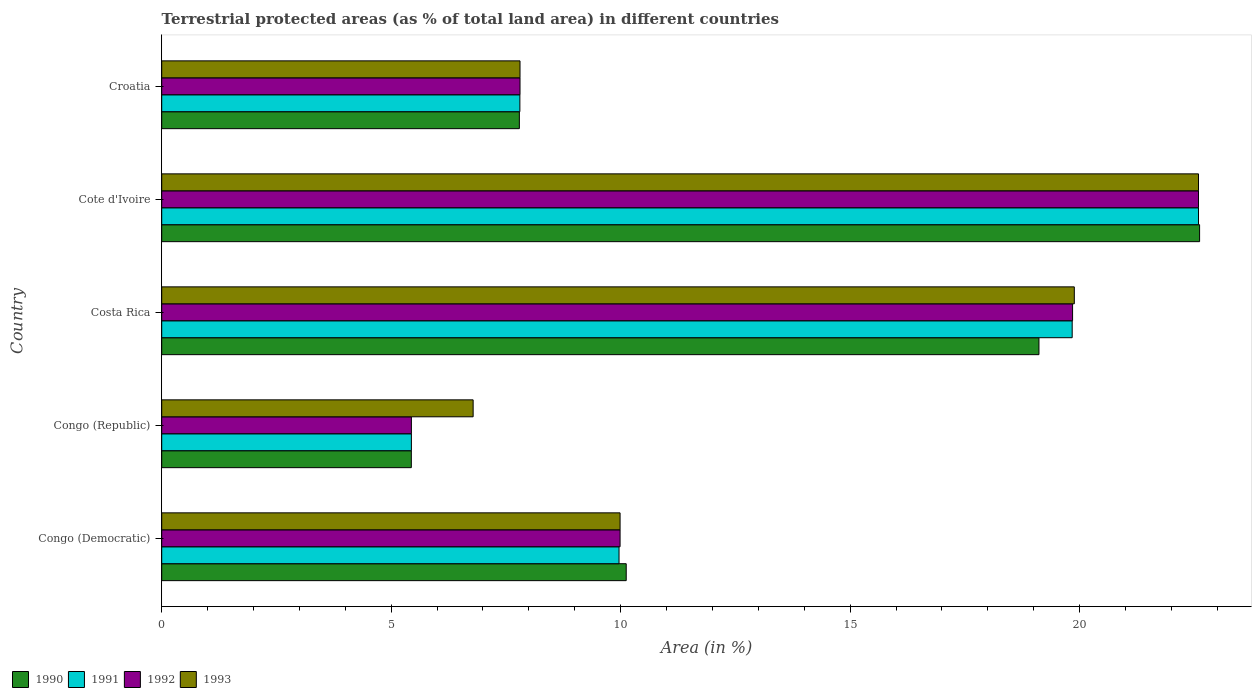Are the number of bars per tick equal to the number of legend labels?
Make the answer very short. Yes. Are the number of bars on each tick of the Y-axis equal?
Provide a succinct answer. Yes. How many bars are there on the 5th tick from the top?
Give a very brief answer. 4. What is the label of the 3rd group of bars from the top?
Give a very brief answer. Costa Rica. What is the percentage of terrestrial protected land in 1992 in Cote d'Ivoire?
Make the answer very short. 22.59. Across all countries, what is the maximum percentage of terrestrial protected land in 1993?
Your response must be concise. 22.59. Across all countries, what is the minimum percentage of terrestrial protected land in 1993?
Ensure brevity in your answer.  6.79. In which country was the percentage of terrestrial protected land in 1992 maximum?
Your response must be concise. Cote d'Ivoire. In which country was the percentage of terrestrial protected land in 1991 minimum?
Your answer should be very brief. Congo (Republic). What is the total percentage of terrestrial protected land in 1990 in the graph?
Offer a terse response. 65.08. What is the difference between the percentage of terrestrial protected land in 1991 in Costa Rica and that in Croatia?
Provide a short and direct response. 12.03. What is the difference between the percentage of terrestrial protected land in 1992 in Congo (Democratic) and the percentage of terrestrial protected land in 1993 in Congo (Republic)?
Provide a succinct answer. 3.2. What is the average percentage of terrestrial protected land in 1991 per country?
Ensure brevity in your answer.  13.13. What is the difference between the percentage of terrestrial protected land in 1993 and percentage of terrestrial protected land in 1991 in Congo (Republic)?
Offer a terse response. 1.35. What is the ratio of the percentage of terrestrial protected land in 1990 in Congo (Republic) to that in Cote d'Ivoire?
Provide a succinct answer. 0.24. Is the percentage of terrestrial protected land in 1992 in Congo (Democratic) less than that in Congo (Republic)?
Offer a terse response. No. Is the difference between the percentage of terrestrial protected land in 1993 in Cote d'Ivoire and Croatia greater than the difference between the percentage of terrestrial protected land in 1991 in Cote d'Ivoire and Croatia?
Your answer should be compact. No. What is the difference between the highest and the second highest percentage of terrestrial protected land in 1992?
Make the answer very short. 2.74. What is the difference between the highest and the lowest percentage of terrestrial protected land in 1991?
Provide a short and direct response. 17.15. Is it the case that in every country, the sum of the percentage of terrestrial protected land in 1993 and percentage of terrestrial protected land in 1991 is greater than the sum of percentage of terrestrial protected land in 1992 and percentage of terrestrial protected land in 1990?
Make the answer very short. No. Is it the case that in every country, the sum of the percentage of terrestrial protected land in 1993 and percentage of terrestrial protected land in 1990 is greater than the percentage of terrestrial protected land in 1991?
Make the answer very short. Yes. How many bars are there?
Offer a very short reply. 20. Are all the bars in the graph horizontal?
Keep it short and to the point. Yes. Does the graph contain any zero values?
Make the answer very short. No. Where does the legend appear in the graph?
Provide a succinct answer. Bottom left. What is the title of the graph?
Your answer should be compact. Terrestrial protected areas (as % of total land area) in different countries. What is the label or title of the X-axis?
Provide a succinct answer. Area (in %). What is the Area (in %) of 1990 in Congo (Democratic)?
Make the answer very short. 10.12. What is the Area (in %) of 1991 in Congo (Democratic)?
Your answer should be compact. 9.96. What is the Area (in %) of 1992 in Congo (Democratic)?
Keep it short and to the point. 9.99. What is the Area (in %) of 1993 in Congo (Democratic)?
Your response must be concise. 9.99. What is the Area (in %) in 1990 in Congo (Republic)?
Make the answer very short. 5.44. What is the Area (in %) of 1991 in Congo (Republic)?
Your response must be concise. 5.44. What is the Area (in %) in 1992 in Congo (Republic)?
Offer a terse response. 5.44. What is the Area (in %) of 1993 in Congo (Republic)?
Your response must be concise. 6.79. What is the Area (in %) in 1990 in Costa Rica?
Ensure brevity in your answer.  19.11. What is the Area (in %) in 1991 in Costa Rica?
Your answer should be compact. 19.84. What is the Area (in %) in 1992 in Costa Rica?
Provide a succinct answer. 19.85. What is the Area (in %) in 1993 in Costa Rica?
Provide a succinct answer. 19.88. What is the Area (in %) in 1990 in Cote d'Ivoire?
Make the answer very short. 22.61. What is the Area (in %) in 1991 in Cote d'Ivoire?
Ensure brevity in your answer.  22.59. What is the Area (in %) in 1992 in Cote d'Ivoire?
Ensure brevity in your answer.  22.59. What is the Area (in %) in 1993 in Cote d'Ivoire?
Offer a terse response. 22.59. What is the Area (in %) in 1990 in Croatia?
Your answer should be very brief. 7.79. What is the Area (in %) of 1991 in Croatia?
Make the answer very short. 7.8. What is the Area (in %) in 1992 in Croatia?
Your response must be concise. 7.81. What is the Area (in %) of 1993 in Croatia?
Offer a very short reply. 7.81. Across all countries, what is the maximum Area (in %) of 1990?
Keep it short and to the point. 22.61. Across all countries, what is the maximum Area (in %) of 1991?
Offer a terse response. 22.59. Across all countries, what is the maximum Area (in %) of 1992?
Make the answer very short. 22.59. Across all countries, what is the maximum Area (in %) of 1993?
Give a very brief answer. 22.59. Across all countries, what is the minimum Area (in %) of 1990?
Ensure brevity in your answer.  5.44. Across all countries, what is the minimum Area (in %) in 1991?
Your answer should be very brief. 5.44. Across all countries, what is the minimum Area (in %) of 1992?
Your answer should be very brief. 5.44. Across all countries, what is the minimum Area (in %) of 1993?
Make the answer very short. 6.79. What is the total Area (in %) of 1990 in the graph?
Give a very brief answer. 65.08. What is the total Area (in %) in 1991 in the graph?
Make the answer very short. 65.64. What is the total Area (in %) of 1992 in the graph?
Make the answer very short. 65.67. What is the total Area (in %) in 1993 in the graph?
Give a very brief answer. 67.05. What is the difference between the Area (in %) of 1990 in Congo (Democratic) and that in Congo (Republic)?
Your response must be concise. 4.68. What is the difference between the Area (in %) in 1991 in Congo (Democratic) and that in Congo (Republic)?
Ensure brevity in your answer.  4.52. What is the difference between the Area (in %) in 1992 in Congo (Democratic) and that in Congo (Republic)?
Give a very brief answer. 4.55. What is the difference between the Area (in %) in 1993 in Congo (Democratic) and that in Congo (Republic)?
Your answer should be compact. 3.2. What is the difference between the Area (in %) in 1990 in Congo (Democratic) and that in Costa Rica?
Keep it short and to the point. -8.99. What is the difference between the Area (in %) of 1991 in Congo (Democratic) and that in Costa Rica?
Offer a terse response. -9.87. What is the difference between the Area (in %) in 1992 in Congo (Democratic) and that in Costa Rica?
Your answer should be very brief. -9.86. What is the difference between the Area (in %) in 1993 in Congo (Democratic) and that in Costa Rica?
Keep it short and to the point. -9.9. What is the difference between the Area (in %) of 1990 in Congo (Democratic) and that in Cote d'Ivoire?
Keep it short and to the point. -12.49. What is the difference between the Area (in %) of 1991 in Congo (Democratic) and that in Cote d'Ivoire?
Keep it short and to the point. -12.63. What is the difference between the Area (in %) of 1992 in Congo (Democratic) and that in Cote d'Ivoire?
Keep it short and to the point. -12.6. What is the difference between the Area (in %) of 1993 in Congo (Democratic) and that in Cote d'Ivoire?
Your answer should be compact. -12.6. What is the difference between the Area (in %) of 1990 in Congo (Democratic) and that in Croatia?
Make the answer very short. 2.33. What is the difference between the Area (in %) in 1991 in Congo (Democratic) and that in Croatia?
Ensure brevity in your answer.  2.16. What is the difference between the Area (in %) in 1992 in Congo (Democratic) and that in Croatia?
Your answer should be compact. 2.18. What is the difference between the Area (in %) of 1993 in Congo (Democratic) and that in Croatia?
Offer a very short reply. 2.18. What is the difference between the Area (in %) of 1990 in Congo (Republic) and that in Costa Rica?
Provide a short and direct response. -13.67. What is the difference between the Area (in %) in 1991 in Congo (Republic) and that in Costa Rica?
Make the answer very short. -14.4. What is the difference between the Area (in %) of 1992 in Congo (Republic) and that in Costa Rica?
Offer a very short reply. -14.41. What is the difference between the Area (in %) of 1993 in Congo (Republic) and that in Costa Rica?
Your answer should be compact. -13.1. What is the difference between the Area (in %) of 1990 in Congo (Republic) and that in Cote d'Ivoire?
Your answer should be compact. -17.17. What is the difference between the Area (in %) in 1991 in Congo (Republic) and that in Cote d'Ivoire?
Offer a very short reply. -17.15. What is the difference between the Area (in %) of 1992 in Congo (Republic) and that in Cote d'Ivoire?
Keep it short and to the point. -17.15. What is the difference between the Area (in %) of 1993 in Congo (Republic) and that in Cote d'Ivoire?
Make the answer very short. -15.8. What is the difference between the Area (in %) of 1990 in Congo (Republic) and that in Croatia?
Make the answer very short. -2.35. What is the difference between the Area (in %) in 1991 in Congo (Republic) and that in Croatia?
Give a very brief answer. -2.36. What is the difference between the Area (in %) in 1992 in Congo (Republic) and that in Croatia?
Give a very brief answer. -2.37. What is the difference between the Area (in %) in 1993 in Congo (Republic) and that in Croatia?
Your answer should be very brief. -1.02. What is the difference between the Area (in %) of 1991 in Costa Rica and that in Cote d'Ivoire?
Make the answer very short. -2.75. What is the difference between the Area (in %) of 1992 in Costa Rica and that in Cote d'Ivoire?
Your response must be concise. -2.74. What is the difference between the Area (in %) in 1993 in Costa Rica and that in Cote d'Ivoire?
Provide a succinct answer. -2.71. What is the difference between the Area (in %) of 1990 in Costa Rica and that in Croatia?
Your answer should be compact. 11.32. What is the difference between the Area (in %) in 1991 in Costa Rica and that in Croatia?
Keep it short and to the point. 12.03. What is the difference between the Area (in %) in 1992 in Costa Rica and that in Croatia?
Your response must be concise. 12.04. What is the difference between the Area (in %) in 1993 in Costa Rica and that in Croatia?
Your answer should be very brief. 12.08. What is the difference between the Area (in %) of 1990 in Cote d'Ivoire and that in Croatia?
Give a very brief answer. 14.82. What is the difference between the Area (in %) of 1991 in Cote d'Ivoire and that in Croatia?
Provide a succinct answer. 14.79. What is the difference between the Area (in %) of 1992 in Cote d'Ivoire and that in Croatia?
Your answer should be very brief. 14.78. What is the difference between the Area (in %) in 1993 in Cote d'Ivoire and that in Croatia?
Your response must be concise. 14.78. What is the difference between the Area (in %) of 1990 in Congo (Democratic) and the Area (in %) of 1991 in Congo (Republic)?
Give a very brief answer. 4.68. What is the difference between the Area (in %) in 1990 in Congo (Democratic) and the Area (in %) in 1992 in Congo (Republic)?
Your answer should be compact. 4.68. What is the difference between the Area (in %) of 1990 in Congo (Democratic) and the Area (in %) of 1993 in Congo (Republic)?
Provide a short and direct response. 3.34. What is the difference between the Area (in %) in 1991 in Congo (Democratic) and the Area (in %) in 1992 in Congo (Republic)?
Keep it short and to the point. 4.52. What is the difference between the Area (in %) in 1991 in Congo (Democratic) and the Area (in %) in 1993 in Congo (Republic)?
Give a very brief answer. 3.18. What is the difference between the Area (in %) in 1992 in Congo (Democratic) and the Area (in %) in 1993 in Congo (Republic)?
Provide a short and direct response. 3.2. What is the difference between the Area (in %) in 1990 in Congo (Democratic) and the Area (in %) in 1991 in Costa Rica?
Make the answer very short. -9.72. What is the difference between the Area (in %) in 1990 in Congo (Democratic) and the Area (in %) in 1992 in Costa Rica?
Your response must be concise. -9.73. What is the difference between the Area (in %) of 1990 in Congo (Democratic) and the Area (in %) of 1993 in Costa Rica?
Give a very brief answer. -9.76. What is the difference between the Area (in %) of 1991 in Congo (Democratic) and the Area (in %) of 1992 in Costa Rica?
Provide a succinct answer. -9.88. What is the difference between the Area (in %) of 1991 in Congo (Democratic) and the Area (in %) of 1993 in Costa Rica?
Your answer should be compact. -9.92. What is the difference between the Area (in %) of 1992 in Congo (Democratic) and the Area (in %) of 1993 in Costa Rica?
Offer a very short reply. -9.9. What is the difference between the Area (in %) in 1990 in Congo (Democratic) and the Area (in %) in 1991 in Cote d'Ivoire?
Your answer should be compact. -12.47. What is the difference between the Area (in %) of 1990 in Congo (Democratic) and the Area (in %) of 1992 in Cote d'Ivoire?
Ensure brevity in your answer.  -12.47. What is the difference between the Area (in %) of 1990 in Congo (Democratic) and the Area (in %) of 1993 in Cote d'Ivoire?
Your answer should be compact. -12.47. What is the difference between the Area (in %) in 1991 in Congo (Democratic) and the Area (in %) in 1992 in Cote d'Ivoire?
Ensure brevity in your answer.  -12.63. What is the difference between the Area (in %) in 1991 in Congo (Democratic) and the Area (in %) in 1993 in Cote d'Ivoire?
Provide a short and direct response. -12.63. What is the difference between the Area (in %) of 1992 in Congo (Democratic) and the Area (in %) of 1993 in Cote d'Ivoire?
Your answer should be compact. -12.6. What is the difference between the Area (in %) of 1990 in Congo (Democratic) and the Area (in %) of 1991 in Croatia?
Ensure brevity in your answer.  2.32. What is the difference between the Area (in %) of 1990 in Congo (Democratic) and the Area (in %) of 1992 in Croatia?
Your answer should be compact. 2.31. What is the difference between the Area (in %) of 1990 in Congo (Democratic) and the Area (in %) of 1993 in Croatia?
Keep it short and to the point. 2.31. What is the difference between the Area (in %) of 1991 in Congo (Democratic) and the Area (in %) of 1992 in Croatia?
Offer a very short reply. 2.16. What is the difference between the Area (in %) of 1991 in Congo (Democratic) and the Area (in %) of 1993 in Croatia?
Your answer should be very brief. 2.16. What is the difference between the Area (in %) in 1992 in Congo (Democratic) and the Area (in %) in 1993 in Croatia?
Keep it short and to the point. 2.18. What is the difference between the Area (in %) of 1990 in Congo (Republic) and the Area (in %) of 1991 in Costa Rica?
Offer a very short reply. -14.4. What is the difference between the Area (in %) in 1990 in Congo (Republic) and the Area (in %) in 1992 in Costa Rica?
Give a very brief answer. -14.41. What is the difference between the Area (in %) in 1990 in Congo (Republic) and the Area (in %) in 1993 in Costa Rica?
Give a very brief answer. -14.45. What is the difference between the Area (in %) in 1991 in Congo (Republic) and the Area (in %) in 1992 in Costa Rica?
Offer a terse response. -14.41. What is the difference between the Area (in %) of 1991 in Congo (Republic) and the Area (in %) of 1993 in Costa Rica?
Offer a terse response. -14.44. What is the difference between the Area (in %) in 1992 in Congo (Republic) and the Area (in %) in 1993 in Costa Rica?
Offer a terse response. -14.44. What is the difference between the Area (in %) of 1990 in Congo (Republic) and the Area (in %) of 1991 in Cote d'Ivoire?
Your response must be concise. -17.15. What is the difference between the Area (in %) of 1990 in Congo (Republic) and the Area (in %) of 1992 in Cote d'Ivoire?
Offer a terse response. -17.15. What is the difference between the Area (in %) in 1990 in Congo (Republic) and the Area (in %) in 1993 in Cote d'Ivoire?
Your answer should be compact. -17.15. What is the difference between the Area (in %) in 1991 in Congo (Republic) and the Area (in %) in 1992 in Cote d'Ivoire?
Keep it short and to the point. -17.15. What is the difference between the Area (in %) in 1991 in Congo (Republic) and the Area (in %) in 1993 in Cote d'Ivoire?
Your answer should be compact. -17.15. What is the difference between the Area (in %) in 1992 in Congo (Republic) and the Area (in %) in 1993 in Cote d'Ivoire?
Keep it short and to the point. -17.15. What is the difference between the Area (in %) of 1990 in Congo (Republic) and the Area (in %) of 1991 in Croatia?
Give a very brief answer. -2.37. What is the difference between the Area (in %) in 1990 in Congo (Republic) and the Area (in %) in 1992 in Croatia?
Your answer should be very brief. -2.37. What is the difference between the Area (in %) in 1990 in Congo (Republic) and the Area (in %) in 1993 in Croatia?
Your answer should be compact. -2.37. What is the difference between the Area (in %) of 1991 in Congo (Republic) and the Area (in %) of 1992 in Croatia?
Give a very brief answer. -2.37. What is the difference between the Area (in %) of 1991 in Congo (Republic) and the Area (in %) of 1993 in Croatia?
Give a very brief answer. -2.37. What is the difference between the Area (in %) of 1992 in Congo (Republic) and the Area (in %) of 1993 in Croatia?
Offer a very short reply. -2.37. What is the difference between the Area (in %) of 1990 in Costa Rica and the Area (in %) of 1991 in Cote d'Ivoire?
Keep it short and to the point. -3.48. What is the difference between the Area (in %) in 1990 in Costa Rica and the Area (in %) in 1992 in Cote d'Ivoire?
Provide a short and direct response. -3.48. What is the difference between the Area (in %) of 1990 in Costa Rica and the Area (in %) of 1993 in Cote d'Ivoire?
Your answer should be compact. -3.48. What is the difference between the Area (in %) in 1991 in Costa Rica and the Area (in %) in 1992 in Cote d'Ivoire?
Offer a terse response. -2.75. What is the difference between the Area (in %) in 1991 in Costa Rica and the Area (in %) in 1993 in Cote d'Ivoire?
Make the answer very short. -2.75. What is the difference between the Area (in %) in 1992 in Costa Rica and the Area (in %) in 1993 in Cote d'Ivoire?
Provide a succinct answer. -2.74. What is the difference between the Area (in %) of 1990 in Costa Rica and the Area (in %) of 1991 in Croatia?
Make the answer very short. 11.31. What is the difference between the Area (in %) in 1990 in Costa Rica and the Area (in %) in 1992 in Croatia?
Keep it short and to the point. 11.31. What is the difference between the Area (in %) in 1990 in Costa Rica and the Area (in %) in 1993 in Croatia?
Your answer should be compact. 11.31. What is the difference between the Area (in %) of 1991 in Costa Rica and the Area (in %) of 1992 in Croatia?
Your answer should be compact. 12.03. What is the difference between the Area (in %) of 1991 in Costa Rica and the Area (in %) of 1993 in Croatia?
Give a very brief answer. 12.03. What is the difference between the Area (in %) in 1992 in Costa Rica and the Area (in %) in 1993 in Croatia?
Provide a succinct answer. 12.04. What is the difference between the Area (in %) of 1990 in Cote d'Ivoire and the Area (in %) of 1991 in Croatia?
Provide a short and direct response. 14.81. What is the difference between the Area (in %) in 1990 in Cote d'Ivoire and the Area (in %) in 1992 in Croatia?
Offer a terse response. 14.81. What is the difference between the Area (in %) in 1990 in Cote d'Ivoire and the Area (in %) in 1993 in Croatia?
Ensure brevity in your answer.  14.81. What is the difference between the Area (in %) in 1991 in Cote d'Ivoire and the Area (in %) in 1992 in Croatia?
Offer a very short reply. 14.78. What is the difference between the Area (in %) of 1991 in Cote d'Ivoire and the Area (in %) of 1993 in Croatia?
Your answer should be very brief. 14.78. What is the difference between the Area (in %) in 1992 in Cote d'Ivoire and the Area (in %) in 1993 in Croatia?
Offer a terse response. 14.78. What is the average Area (in %) of 1990 per country?
Keep it short and to the point. 13.02. What is the average Area (in %) of 1991 per country?
Keep it short and to the point. 13.13. What is the average Area (in %) in 1992 per country?
Your answer should be compact. 13.13. What is the average Area (in %) of 1993 per country?
Your answer should be very brief. 13.41. What is the difference between the Area (in %) in 1990 and Area (in %) in 1991 in Congo (Democratic)?
Your answer should be very brief. 0.16. What is the difference between the Area (in %) of 1990 and Area (in %) of 1992 in Congo (Democratic)?
Make the answer very short. 0.13. What is the difference between the Area (in %) of 1990 and Area (in %) of 1993 in Congo (Democratic)?
Provide a short and direct response. 0.13. What is the difference between the Area (in %) of 1991 and Area (in %) of 1992 in Congo (Democratic)?
Your answer should be very brief. -0.02. What is the difference between the Area (in %) in 1991 and Area (in %) in 1993 in Congo (Democratic)?
Provide a short and direct response. -0.02. What is the difference between the Area (in %) of 1992 and Area (in %) of 1993 in Congo (Democratic)?
Your answer should be compact. -0. What is the difference between the Area (in %) of 1990 and Area (in %) of 1991 in Congo (Republic)?
Keep it short and to the point. -0. What is the difference between the Area (in %) of 1990 and Area (in %) of 1992 in Congo (Republic)?
Ensure brevity in your answer.  -0. What is the difference between the Area (in %) in 1990 and Area (in %) in 1993 in Congo (Republic)?
Offer a terse response. -1.35. What is the difference between the Area (in %) in 1991 and Area (in %) in 1993 in Congo (Republic)?
Ensure brevity in your answer.  -1.35. What is the difference between the Area (in %) in 1992 and Area (in %) in 1993 in Congo (Republic)?
Keep it short and to the point. -1.35. What is the difference between the Area (in %) in 1990 and Area (in %) in 1991 in Costa Rica?
Make the answer very short. -0.72. What is the difference between the Area (in %) of 1990 and Area (in %) of 1992 in Costa Rica?
Offer a terse response. -0.73. What is the difference between the Area (in %) in 1990 and Area (in %) in 1993 in Costa Rica?
Ensure brevity in your answer.  -0.77. What is the difference between the Area (in %) of 1991 and Area (in %) of 1992 in Costa Rica?
Your answer should be compact. -0.01. What is the difference between the Area (in %) of 1991 and Area (in %) of 1993 in Costa Rica?
Provide a short and direct response. -0.05. What is the difference between the Area (in %) of 1992 and Area (in %) of 1993 in Costa Rica?
Offer a very short reply. -0.04. What is the difference between the Area (in %) in 1990 and Area (in %) in 1991 in Cote d'Ivoire?
Your answer should be very brief. 0.02. What is the difference between the Area (in %) in 1990 and Area (in %) in 1992 in Cote d'Ivoire?
Your answer should be compact. 0.02. What is the difference between the Area (in %) of 1990 and Area (in %) of 1993 in Cote d'Ivoire?
Your answer should be very brief. 0.02. What is the difference between the Area (in %) in 1991 and Area (in %) in 1992 in Cote d'Ivoire?
Your response must be concise. 0. What is the difference between the Area (in %) of 1991 and Area (in %) of 1993 in Cote d'Ivoire?
Make the answer very short. 0. What is the difference between the Area (in %) in 1990 and Area (in %) in 1991 in Croatia?
Your answer should be compact. -0.01. What is the difference between the Area (in %) in 1990 and Area (in %) in 1992 in Croatia?
Offer a very short reply. -0.01. What is the difference between the Area (in %) of 1990 and Area (in %) of 1993 in Croatia?
Offer a terse response. -0.01. What is the difference between the Area (in %) of 1991 and Area (in %) of 1992 in Croatia?
Offer a very short reply. -0. What is the difference between the Area (in %) in 1991 and Area (in %) in 1993 in Croatia?
Provide a short and direct response. -0. What is the ratio of the Area (in %) in 1990 in Congo (Democratic) to that in Congo (Republic)?
Give a very brief answer. 1.86. What is the ratio of the Area (in %) in 1991 in Congo (Democratic) to that in Congo (Republic)?
Provide a succinct answer. 1.83. What is the ratio of the Area (in %) in 1992 in Congo (Democratic) to that in Congo (Republic)?
Your answer should be compact. 1.84. What is the ratio of the Area (in %) of 1993 in Congo (Democratic) to that in Congo (Republic)?
Your response must be concise. 1.47. What is the ratio of the Area (in %) in 1990 in Congo (Democratic) to that in Costa Rica?
Give a very brief answer. 0.53. What is the ratio of the Area (in %) of 1991 in Congo (Democratic) to that in Costa Rica?
Provide a succinct answer. 0.5. What is the ratio of the Area (in %) in 1992 in Congo (Democratic) to that in Costa Rica?
Your answer should be very brief. 0.5. What is the ratio of the Area (in %) in 1993 in Congo (Democratic) to that in Costa Rica?
Offer a terse response. 0.5. What is the ratio of the Area (in %) of 1990 in Congo (Democratic) to that in Cote d'Ivoire?
Ensure brevity in your answer.  0.45. What is the ratio of the Area (in %) of 1991 in Congo (Democratic) to that in Cote d'Ivoire?
Your response must be concise. 0.44. What is the ratio of the Area (in %) in 1992 in Congo (Democratic) to that in Cote d'Ivoire?
Ensure brevity in your answer.  0.44. What is the ratio of the Area (in %) of 1993 in Congo (Democratic) to that in Cote d'Ivoire?
Ensure brevity in your answer.  0.44. What is the ratio of the Area (in %) of 1990 in Congo (Democratic) to that in Croatia?
Provide a short and direct response. 1.3. What is the ratio of the Area (in %) of 1991 in Congo (Democratic) to that in Croatia?
Your answer should be very brief. 1.28. What is the ratio of the Area (in %) in 1992 in Congo (Democratic) to that in Croatia?
Make the answer very short. 1.28. What is the ratio of the Area (in %) of 1993 in Congo (Democratic) to that in Croatia?
Make the answer very short. 1.28. What is the ratio of the Area (in %) of 1990 in Congo (Republic) to that in Costa Rica?
Your answer should be compact. 0.28. What is the ratio of the Area (in %) of 1991 in Congo (Republic) to that in Costa Rica?
Ensure brevity in your answer.  0.27. What is the ratio of the Area (in %) of 1992 in Congo (Republic) to that in Costa Rica?
Your answer should be compact. 0.27. What is the ratio of the Area (in %) of 1993 in Congo (Republic) to that in Costa Rica?
Your answer should be very brief. 0.34. What is the ratio of the Area (in %) in 1990 in Congo (Republic) to that in Cote d'Ivoire?
Your response must be concise. 0.24. What is the ratio of the Area (in %) in 1991 in Congo (Republic) to that in Cote d'Ivoire?
Ensure brevity in your answer.  0.24. What is the ratio of the Area (in %) in 1992 in Congo (Republic) to that in Cote d'Ivoire?
Your response must be concise. 0.24. What is the ratio of the Area (in %) of 1993 in Congo (Republic) to that in Cote d'Ivoire?
Your answer should be very brief. 0.3. What is the ratio of the Area (in %) in 1990 in Congo (Republic) to that in Croatia?
Your answer should be compact. 0.7. What is the ratio of the Area (in %) of 1991 in Congo (Republic) to that in Croatia?
Provide a succinct answer. 0.7. What is the ratio of the Area (in %) in 1992 in Congo (Republic) to that in Croatia?
Your answer should be compact. 0.7. What is the ratio of the Area (in %) in 1993 in Congo (Republic) to that in Croatia?
Keep it short and to the point. 0.87. What is the ratio of the Area (in %) in 1990 in Costa Rica to that in Cote d'Ivoire?
Provide a short and direct response. 0.85. What is the ratio of the Area (in %) in 1991 in Costa Rica to that in Cote d'Ivoire?
Offer a terse response. 0.88. What is the ratio of the Area (in %) of 1992 in Costa Rica to that in Cote d'Ivoire?
Make the answer very short. 0.88. What is the ratio of the Area (in %) in 1993 in Costa Rica to that in Cote d'Ivoire?
Keep it short and to the point. 0.88. What is the ratio of the Area (in %) of 1990 in Costa Rica to that in Croatia?
Provide a short and direct response. 2.45. What is the ratio of the Area (in %) of 1991 in Costa Rica to that in Croatia?
Keep it short and to the point. 2.54. What is the ratio of the Area (in %) of 1992 in Costa Rica to that in Croatia?
Your answer should be compact. 2.54. What is the ratio of the Area (in %) of 1993 in Costa Rica to that in Croatia?
Keep it short and to the point. 2.55. What is the ratio of the Area (in %) in 1990 in Cote d'Ivoire to that in Croatia?
Make the answer very short. 2.9. What is the ratio of the Area (in %) of 1991 in Cote d'Ivoire to that in Croatia?
Your response must be concise. 2.89. What is the ratio of the Area (in %) in 1992 in Cote d'Ivoire to that in Croatia?
Ensure brevity in your answer.  2.89. What is the ratio of the Area (in %) in 1993 in Cote d'Ivoire to that in Croatia?
Your answer should be very brief. 2.89. What is the difference between the highest and the second highest Area (in %) of 1991?
Keep it short and to the point. 2.75. What is the difference between the highest and the second highest Area (in %) in 1992?
Keep it short and to the point. 2.74. What is the difference between the highest and the second highest Area (in %) of 1993?
Give a very brief answer. 2.71. What is the difference between the highest and the lowest Area (in %) of 1990?
Provide a succinct answer. 17.17. What is the difference between the highest and the lowest Area (in %) of 1991?
Offer a terse response. 17.15. What is the difference between the highest and the lowest Area (in %) of 1992?
Make the answer very short. 17.15. What is the difference between the highest and the lowest Area (in %) of 1993?
Your answer should be compact. 15.8. 